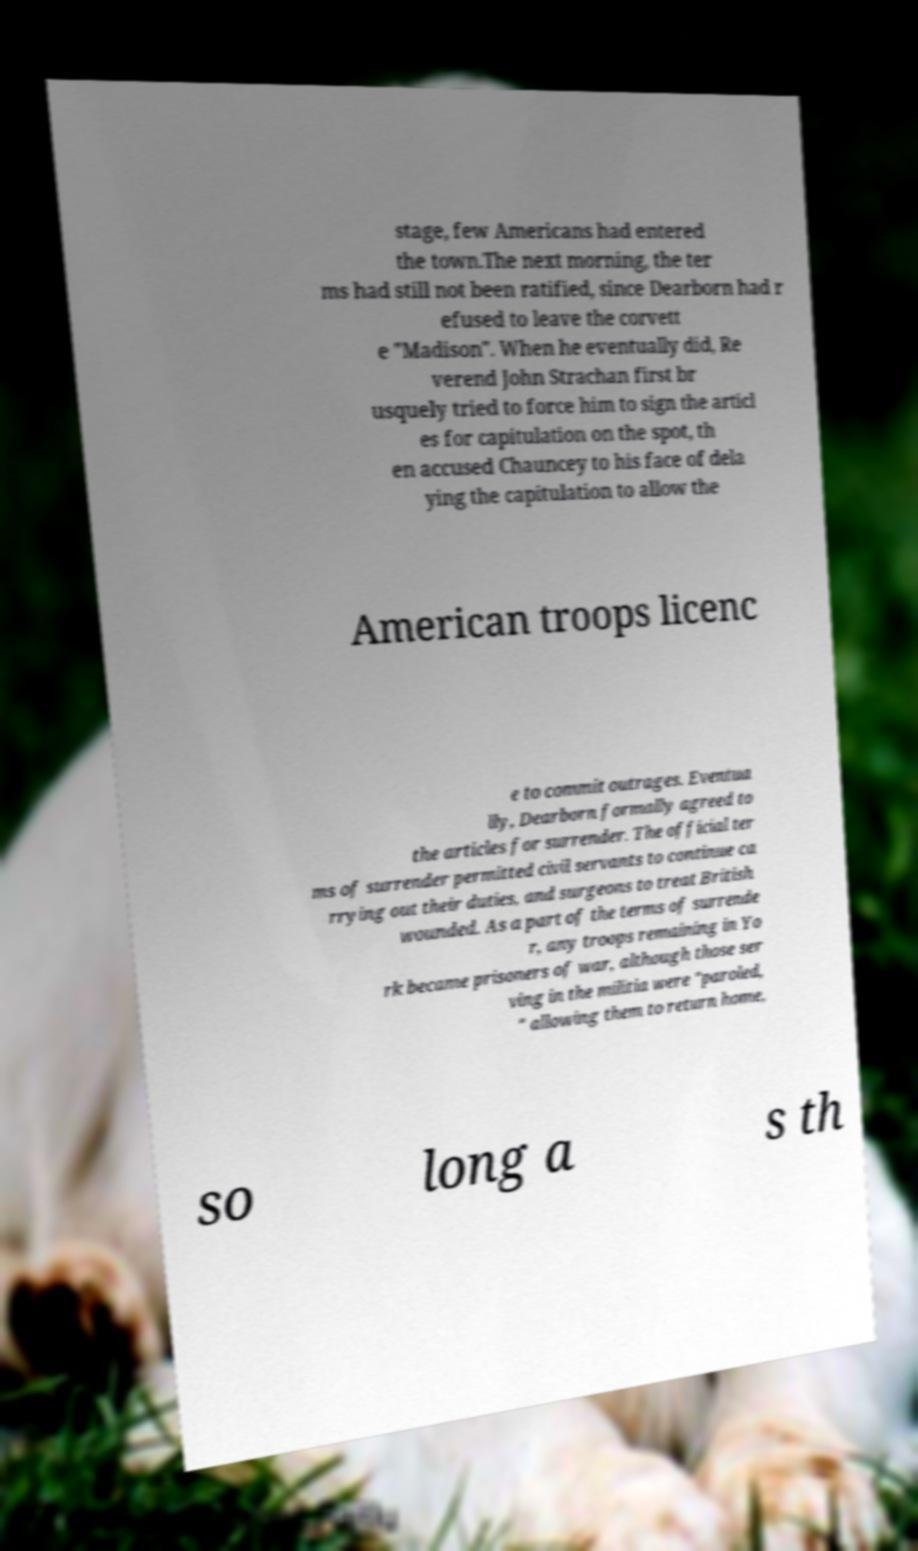What messages or text are displayed in this image? I need them in a readable, typed format. stage, few Americans had entered the town.The next morning, the ter ms had still not been ratified, since Dearborn had r efused to leave the corvett e "Madison". When he eventually did, Re verend John Strachan first br usquely tried to force him to sign the articl es for capitulation on the spot, th en accused Chauncey to his face of dela ying the capitulation to allow the American troops licenc e to commit outrages. Eventua lly, Dearborn formally agreed to the articles for surrender. The official ter ms of surrender permitted civil servants to continue ca rrying out their duties, and surgeons to treat British wounded. As a part of the terms of surrende r, any troops remaining in Yo rk became prisoners of war, although those ser ving in the militia were "paroled, " allowing them to return home, so long a s th 